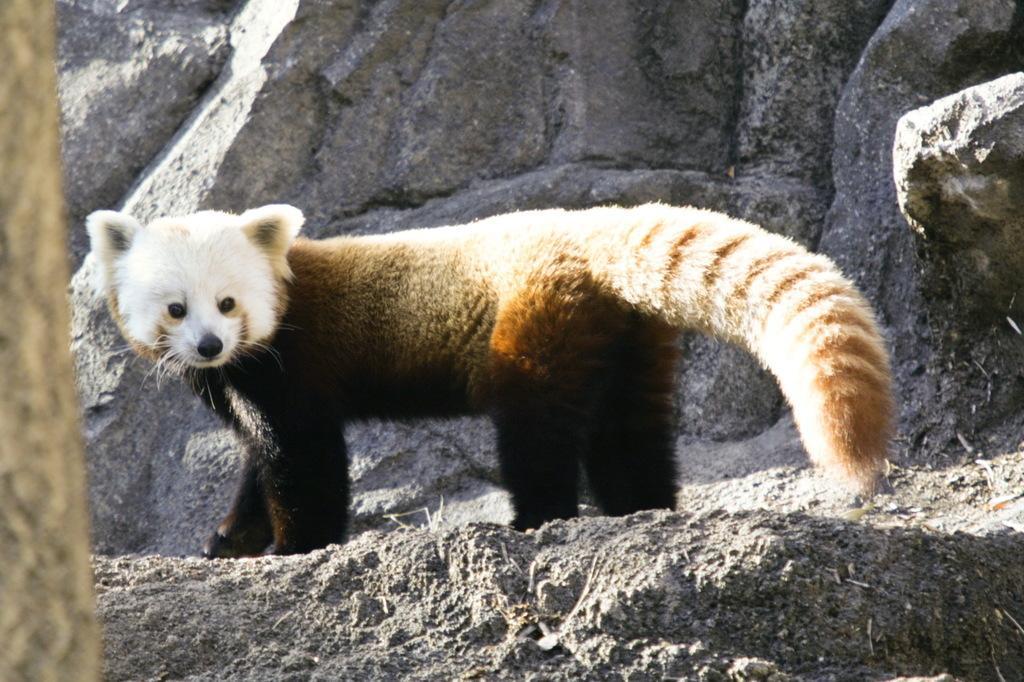Can you describe this image briefly? In this image we can see an animal standing on the rock. 